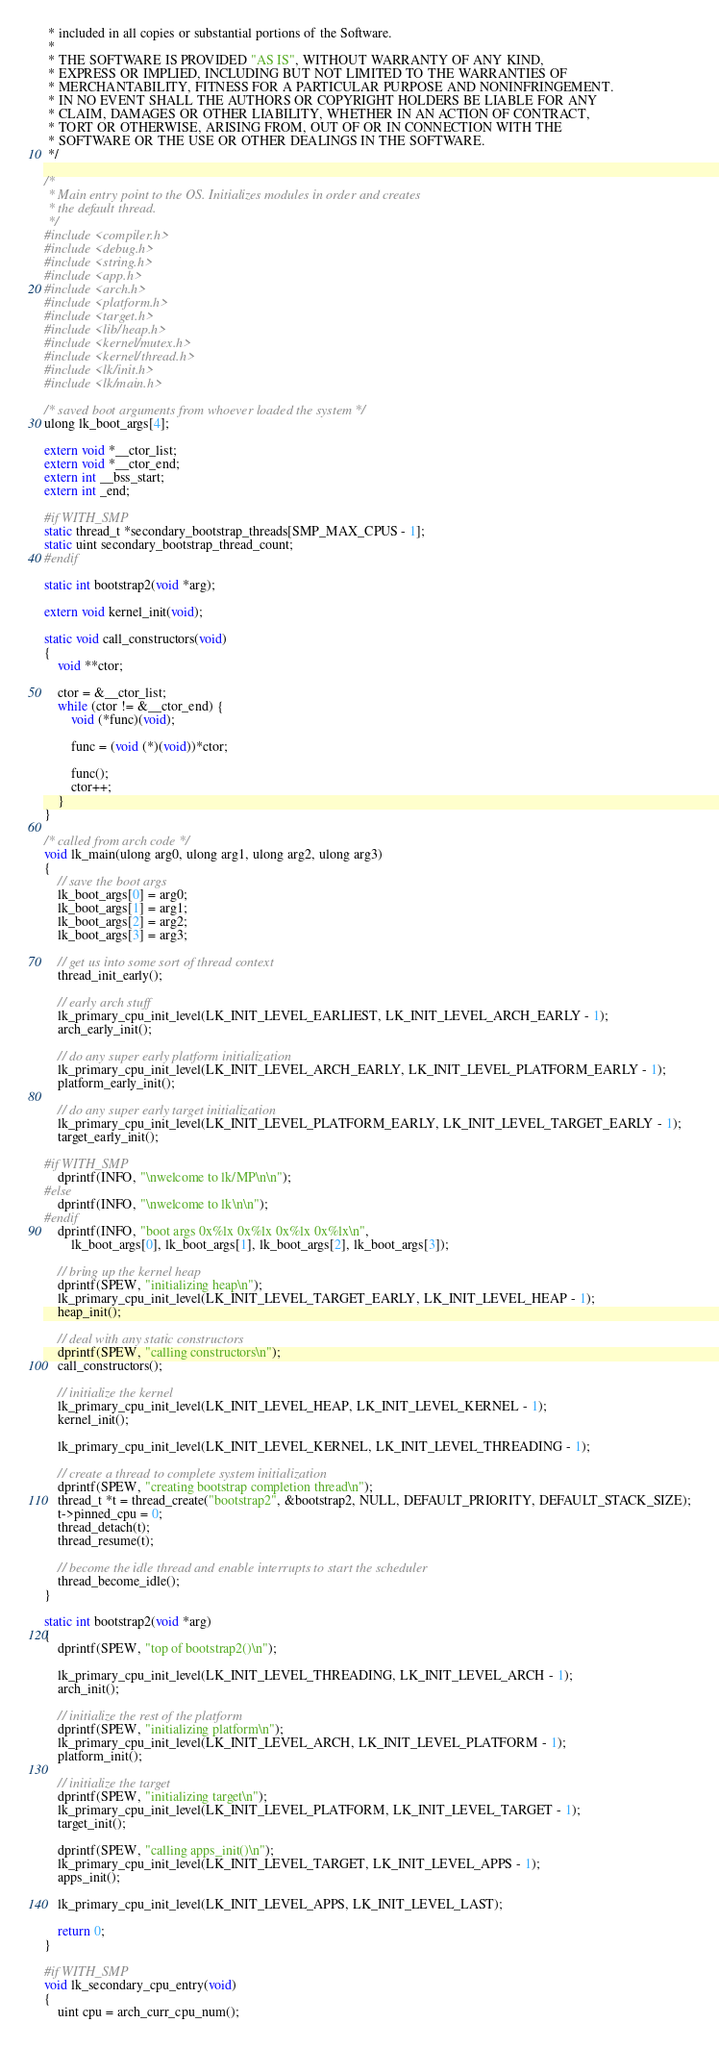<code> <loc_0><loc_0><loc_500><loc_500><_C_> * included in all copies or substantial portions of the Software.
 *
 * THE SOFTWARE IS PROVIDED "AS IS", WITHOUT WARRANTY OF ANY KIND,
 * EXPRESS OR IMPLIED, INCLUDING BUT NOT LIMITED TO THE WARRANTIES OF
 * MERCHANTABILITY, FITNESS FOR A PARTICULAR PURPOSE AND NONINFRINGEMENT.
 * IN NO EVENT SHALL THE AUTHORS OR COPYRIGHT HOLDERS BE LIABLE FOR ANY
 * CLAIM, DAMAGES OR OTHER LIABILITY, WHETHER IN AN ACTION OF CONTRACT,
 * TORT OR OTHERWISE, ARISING FROM, OUT OF OR IN CONNECTION WITH THE
 * SOFTWARE OR THE USE OR OTHER DEALINGS IN THE SOFTWARE.
 */

/*
 * Main entry point to the OS. Initializes modules in order and creates
 * the default thread.
 */
#include <compiler.h>
#include <debug.h>
#include <string.h>
#include <app.h>
#include <arch.h>
#include <platform.h>
#include <target.h>
#include <lib/heap.h>
#include <kernel/mutex.h>
#include <kernel/thread.h>
#include <lk/init.h>
#include <lk/main.h>

/* saved boot arguments from whoever loaded the system */
ulong lk_boot_args[4];

extern void *__ctor_list;
extern void *__ctor_end;
extern int __bss_start;
extern int _end;

#if WITH_SMP
static thread_t *secondary_bootstrap_threads[SMP_MAX_CPUS - 1];
static uint secondary_bootstrap_thread_count;
#endif

static int bootstrap2(void *arg);

extern void kernel_init(void);

static void call_constructors(void)
{
	void **ctor;

	ctor = &__ctor_list;
	while (ctor != &__ctor_end) {
		void (*func)(void);

		func = (void (*)(void))*ctor;

		func();
		ctor++;
	}
}

/* called from arch code */
void lk_main(ulong arg0, ulong arg1, ulong arg2, ulong arg3)
{
	// save the boot args
	lk_boot_args[0] = arg0;
	lk_boot_args[1] = arg1;
	lk_boot_args[2] = arg2;
	lk_boot_args[3] = arg3;

	// get us into some sort of thread context
	thread_init_early();

	// early arch stuff
	lk_primary_cpu_init_level(LK_INIT_LEVEL_EARLIEST, LK_INIT_LEVEL_ARCH_EARLY - 1);
	arch_early_init();

	// do any super early platform initialization
	lk_primary_cpu_init_level(LK_INIT_LEVEL_ARCH_EARLY, LK_INIT_LEVEL_PLATFORM_EARLY - 1);
	platform_early_init();

	// do any super early target initialization
	lk_primary_cpu_init_level(LK_INIT_LEVEL_PLATFORM_EARLY, LK_INIT_LEVEL_TARGET_EARLY - 1);
	target_early_init();

#if WITH_SMP
	dprintf(INFO, "\nwelcome to lk/MP\n\n");
#else
	dprintf(INFO, "\nwelcome to lk\n\n");
#endif
	dprintf(INFO, "boot args 0x%lx 0x%lx 0x%lx 0x%lx\n",
		lk_boot_args[0], lk_boot_args[1], lk_boot_args[2], lk_boot_args[3]);

	// bring up the kernel heap
	dprintf(SPEW, "initializing heap\n");
	lk_primary_cpu_init_level(LK_INIT_LEVEL_TARGET_EARLY, LK_INIT_LEVEL_HEAP - 1);
	heap_init();

	// deal with any static constructors
	dprintf(SPEW, "calling constructors\n");
	call_constructors();

	// initialize the kernel
	lk_primary_cpu_init_level(LK_INIT_LEVEL_HEAP, LK_INIT_LEVEL_KERNEL - 1);
	kernel_init();

	lk_primary_cpu_init_level(LK_INIT_LEVEL_KERNEL, LK_INIT_LEVEL_THREADING - 1);

	// create a thread to complete system initialization
	dprintf(SPEW, "creating bootstrap completion thread\n");
	thread_t *t = thread_create("bootstrap2", &bootstrap2, NULL, DEFAULT_PRIORITY, DEFAULT_STACK_SIZE);
	t->pinned_cpu = 0;
	thread_detach(t);
	thread_resume(t);

	// become the idle thread and enable interrupts to start the scheduler
	thread_become_idle();
}

static int bootstrap2(void *arg)
{
	dprintf(SPEW, "top of bootstrap2()\n");

	lk_primary_cpu_init_level(LK_INIT_LEVEL_THREADING, LK_INIT_LEVEL_ARCH - 1);
	arch_init();

	// initialize the rest of the platform
	dprintf(SPEW, "initializing platform\n");
	lk_primary_cpu_init_level(LK_INIT_LEVEL_ARCH, LK_INIT_LEVEL_PLATFORM - 1);
	platform_init();

	// initialize the target
	dprintf(SPEW, "initializing target\n");
	lk_primary_cpu_init_level(LK_INIT_LEVEL_PLATFORM, LK_INIT_LEVEL_TARGET - 1);
	target_init();

	dprintf(SPEW, "calling apps_init()\n");
	lk_primary_cpu_init_level(LK_INIT_LEVEL_TARGET, LK_INIT_LEVEL_APPS - 1);
	apps_init();

	lk_primary_cpu_init_level(LK_INIT_LEVEL_APPS, LK_INIT_LEVEL_LAST);

	return 0;
}

#if WITH_SMP
void lk_secondary_cpu_entry(void)
{
	uint cpu = arch_curr_cpu_num();
</code> 